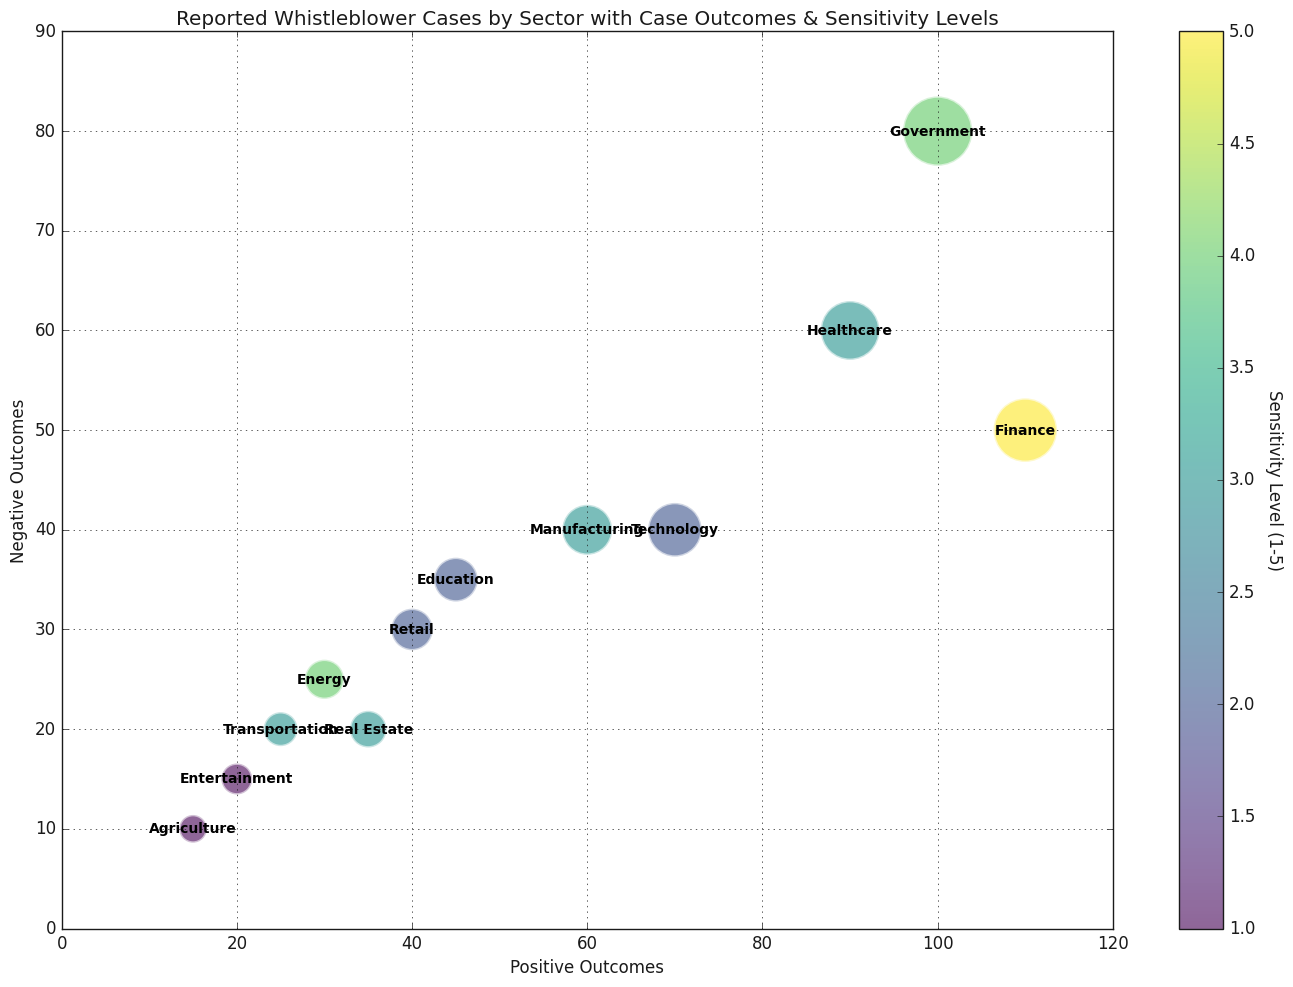Which sector has the highest number of positive outcomes? To determine the sector with the highest number of positive outcomes, we need to look at the x-axis values for all sectors and identify the highest point. The 'Finance' sector is at the farthest right on the scatter plot, which means it has the highest number of positive outcomes.
Answer: Finance Which sector reports the highest sensitivity level? To find the sector with the highest sensitivity level, we need to look at the colors of the bubbles. The 'Finance' sector bubble is the brightest color on the color scale indicating the highest sensitivity level of 5.
Answer: Finance Which two sectors have exactly the same number of negative outcomes but different positive outcomes? By observing the y-axis (negative outcomes), we see that the 'Agriculture' and 'Entertainment' sectors both have their bubbles at the same height of 10 negative outcomes. However, their positions on the x-axis (positive outcomes) are different: Agriculture is at 15 and Entertainment is at 20.
Answer: Agriculture and Entertainment What's the total number of ongoing cases in the sectors with a sensitivity level of 3? The sectors with a sensitivity level of 3 are Healthcare, Manufacturing, Transportation, and Real Estate. The ongoing cases for these sectors are 30, 30, 15, and 15 respectively. Adding these up gives 30 + 30 + 15 + 15 = 90.
Answer: 90 Which sector has the smallest bubble on the chart? The bubble size represents the number of cases, and the smallest bubble corresponds to the smallest number on the chart. 'Agriculture' sector has the smallest bubble with only 40 cases.
Answer: Agriculture Which sector has the same number of positive and negative outcomes? By observing the equal x and y coordinates, we find the 'Healthcare' sector has 90 positive outcomes and 60 negative outcomes, while the sector closest to these values with equal positive and negative outcomes is the 'Agriculture' sector, but it has 15 positive and 10 negative outcomes. Thus, there is no sector with exactly the same positive and negative outcomes.
Answer: None How many sectors have more than 50 negative outcomes? By scanning the y-axis values, we find that the 'Government', 'Healthcare', 'Finance', and 'Manufacturing' sectors have negative outcomes more than 50 (80, 60, 50, and 40 respectively). We need to correct the values which are Healthcare (60), Finance (50), Manufacturing (40) so there are only 3 sectors above value of 50
Answer: 3 